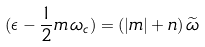<formula> <loc_0><loc_0><loc_500><loc_500>( \epsilon - \frac { 1 } { 2 } m \, \omega _ { c } ) = ( | m | + n ) \, { \widetilde { \omega } }</formula> 